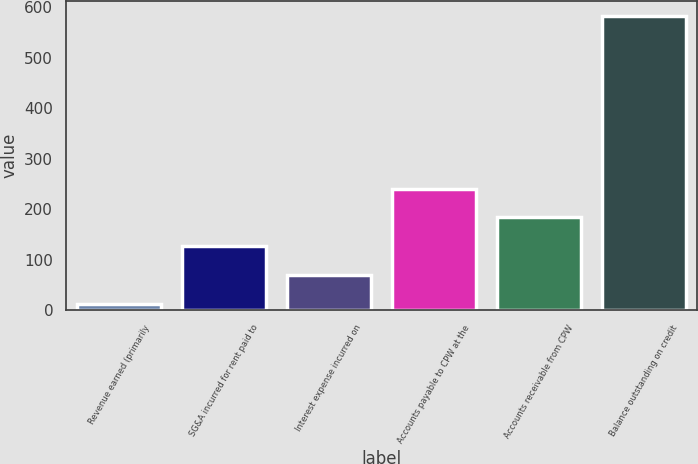<chart> <loc_0><loc_0><loc_500><loc_500><bar_chart><fcel>Revenue earned (primarily<fcel>SG&A incurred for rent paid to<fcel>Interest expense incurred on<fcel>Accounts payable to CPW at the<fcel>Accounts receivable from CPW<fcel>Balance outstanding on credit<nl><fcel>12<fcel>126.4<fcel>69.2<fcel>240.8<fcel>183.6<fcel>584<nl></chart> 